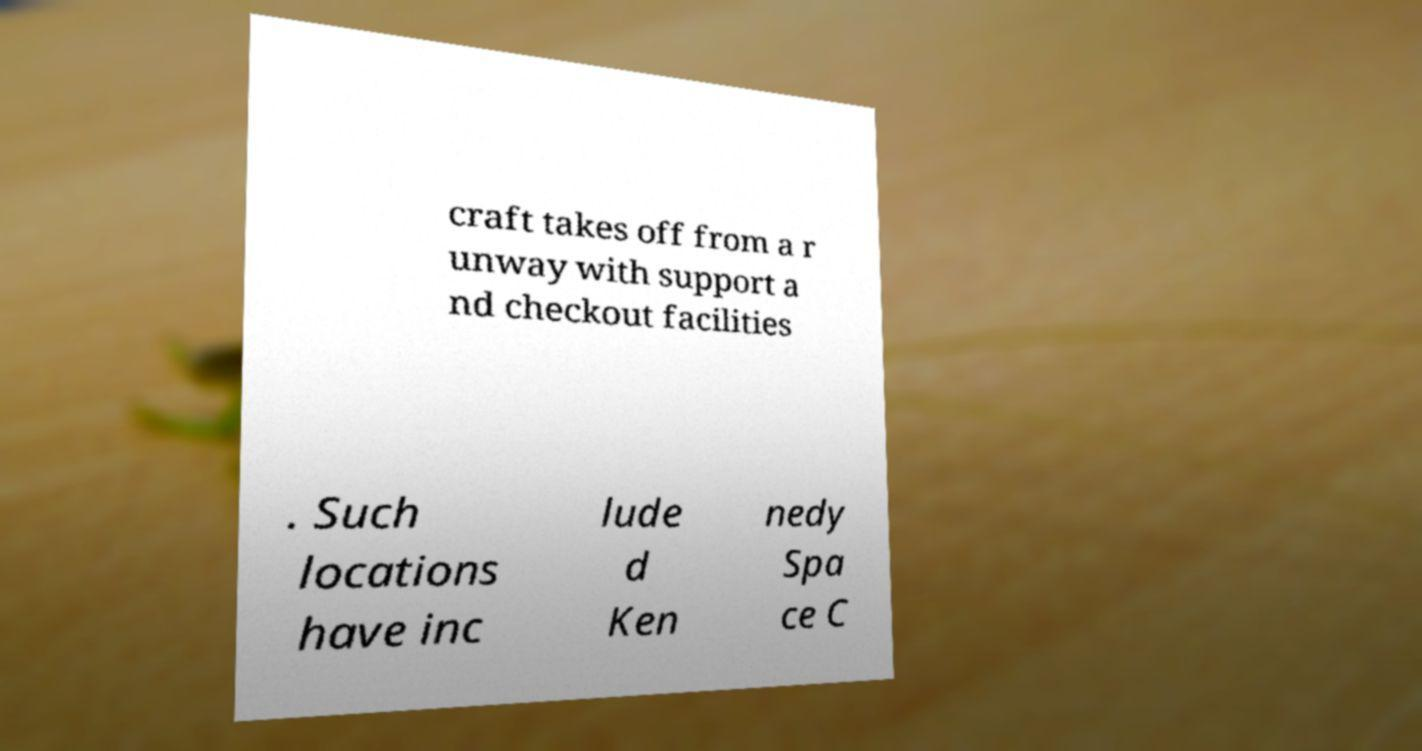Could you extract and type out the text from this image? craft takes off from a r unway with support a nd checkout facilities . Such locations have inc lude d Ken nedy Spa ce C 